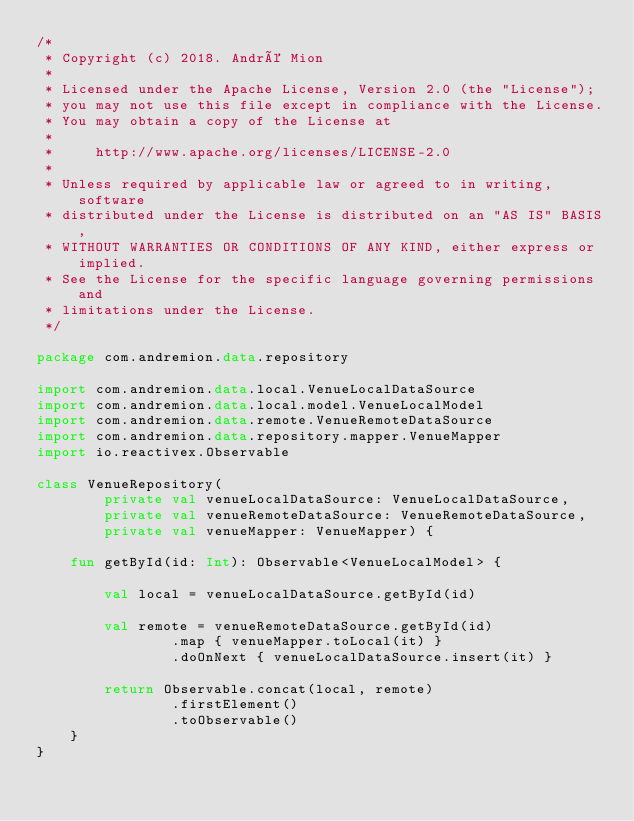Convert code to text. <code><loc_0><loc_0><loc_500><loc_500><_Kotlin_>/*
 * Copyright (c) 2018. André Mion
 *
 * Licensed under the Apache License, Version 2.0 (the "License");
 * you may not use this file except in compliance with the License.
 * You may obtain a copy of the License at
 *
 *     http://www.apache.org/licenses/LICENSE-2.0
 *
 * Unless required by applicable law or agreed to in writing, software
 * distributed under the License is distributed on an "AS IS" BASIS,
 * WITHOUT WARRANTIES OR CONDITIONS OF ANY KIND, either express or implied.
 * See the License for the specific language governing permissions and
 * limitations under the License.
 */

package com.andremion.data.repository

import com.andremion.data.local.VenueLocalDataSource
import com.andremion.data.local.model.VenueLocalModel
import com.andremion.data.remote.VenueRemoteDataSource
import com.andremion.data.repository.mapper.VenueMapper
import io.reactivex.Observable

class VenueRepository(
        private val venueLocalDataSource: VenueLocalDataSource,
        private val venueRemoteDataSource: VenueRemoteDataSource,
        private val venueMapper: VenueMapper) {

    fun getById(id: Int): Observable<VenueLocalModel> {

        val local = venueLocalDataSource.getById(id)

        val remote = venueRemoteDataSource.getById(id)
                .map { venueMapper.toLocal(it) }
                .doOnNext { venueLocalDataSource.insert(it) }

        return Observable.concat(local, remote)
                .firstElement()
                .toObservable()
    }
}
</code> 